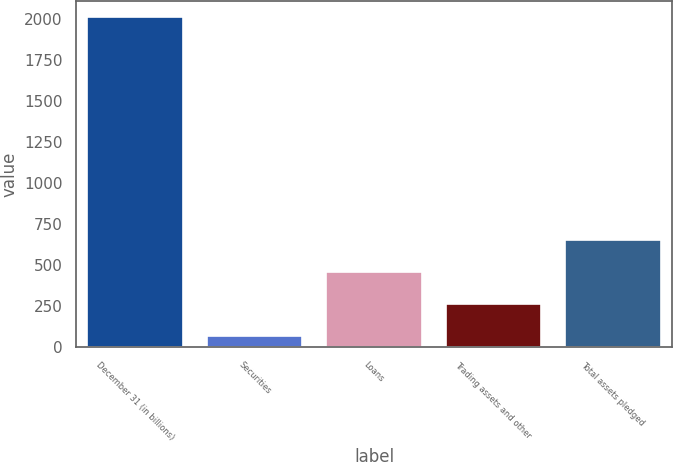<chart> <loc_0><loc_0><loc_500><loc_500><bar_chart><fcel>December 31 (in billions)<fcel>Securities<fcel>Loans<fcel>Trading assets and other<fcel>Total assets pledged<nl><fcel>2013<fcel>68.1<fcel>457.08<fcel>262.59<fcel>651.57<nl></chart> 